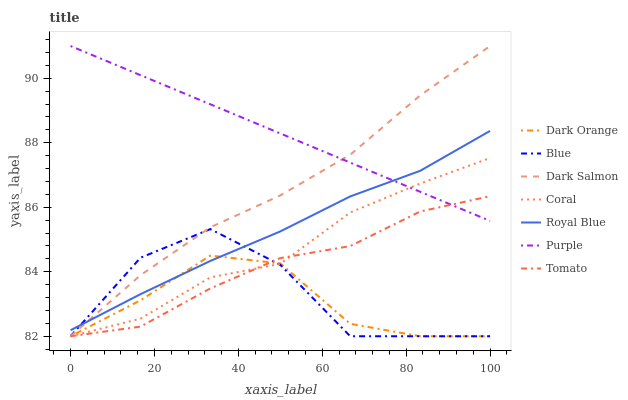Does Dark Orange have the minimum area under the curve?
Answer yes or no. Yes. Does Purple have the maximum area under the curve?
Answer yes or no. Yes. Does Purple have the minimum area under the curve?
Answer yes or no. No. Does Dark Orange have the maximum area under the curve?
Answer yes or no. No. Is Purple the smoothest?
Answer yes or no. Yes. Is Blue the roughest?
Answer yes or no. Yes. Is Dark Orange the smoothest?
Answer yes or no. No. Is Dark Orange the roughest?
Answer yes or no. No. Does Purple have the lowest value?
Answer yes or no. No. Does Dark Salmon have the highest value?
Answer yes or no. Yes. Does Dark Orange have the highest value?
Answer yes or no. No. Is Coral less than Royal Blue?
Answer yes or no. Yes. Is Royal Blue greater than Coral?
Answer yes or no. Yes. Does Blue intersect Dark Orange?
Answer yes or no. Yes. Is Blue less than Dark Orange?
Answer yes or no. No. Is Blue greater than Dark Orange?
Answer yes or no. No. Does Coral intersect Royal Blue?
Answer yes or no. No. 